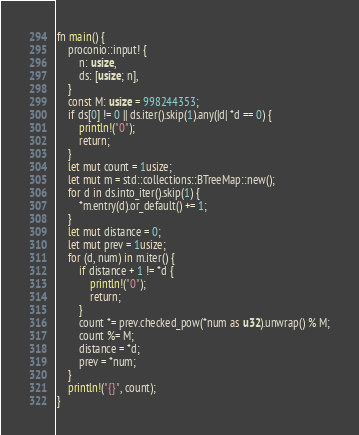<code> <loc_0><loc_0><loc_500><loc_500><_Rust_>fn main() {
    proconio::input! {
        n: usize,
        ds: [usize; n],
    }
    const M: usize = 998244353;
    if ds[0] != 0 || ds.iter().skip(1).any(|d| *d == 0) {
        println!("0");
        return;
    }
    let mut count = 1usize;
    let mut m = std::collections::BTreeMap::new();
    for d in ds.into_iter().skip(1) {
        *m.entry(d).or_default() += 1;
    }
    let mut distance = 0;
    let mut prev = 1usize;
    for (d, num) in m.iter() {
        if distance + 1 != *d {
            println!("0");
            return;
        }
        count *= prev.checked_pow(*num as u32).unwrap() % M;
        count %= M;
        distance = *d;
        prev = *num;
    }
    println!("{}", count);
}
</code> 